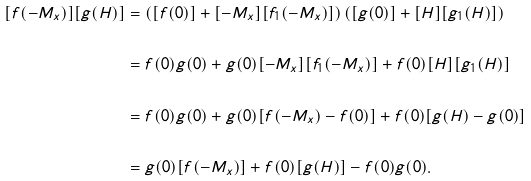Convert formula to latex. <formula><loc_0><loc_0><loc_500><loc_500>[ f ( - M _ { x } ) ] [ g ( H ) ] & = \left ( [ f ( 0 ) ] + [ - M _ { x } ] [ f _ { 1 } ( - M _ { x } ) ] \right ) \left ( [ g ( 0 ) ] + [ H ] [ g _ { 1 } ( H ) ] \right ) \\ \\ & = f ( 0 ) g ( 0 ) + g ( 0 ) [ - M _ { x } ] [ f _ { 1 } ( - M _ { x } ) ] + f ( 0 ) [ H ] [ g _ { 1 } ( H ) ] \\ \\ & = f ( 0 ) g ( 0 ) + g ( 0 ) [ f ( - M _ { x } ) - f ( 0 ) ] + f ( 0 ) [ g ( H ) - g ( 0 ) ] \\ \\ & = g ( 0 ) [ f ( - M _ { x } ) ] + f ( 0 ) [ g ( H ) ] - f ( 0 ) g ( 0 ) .</formula> 